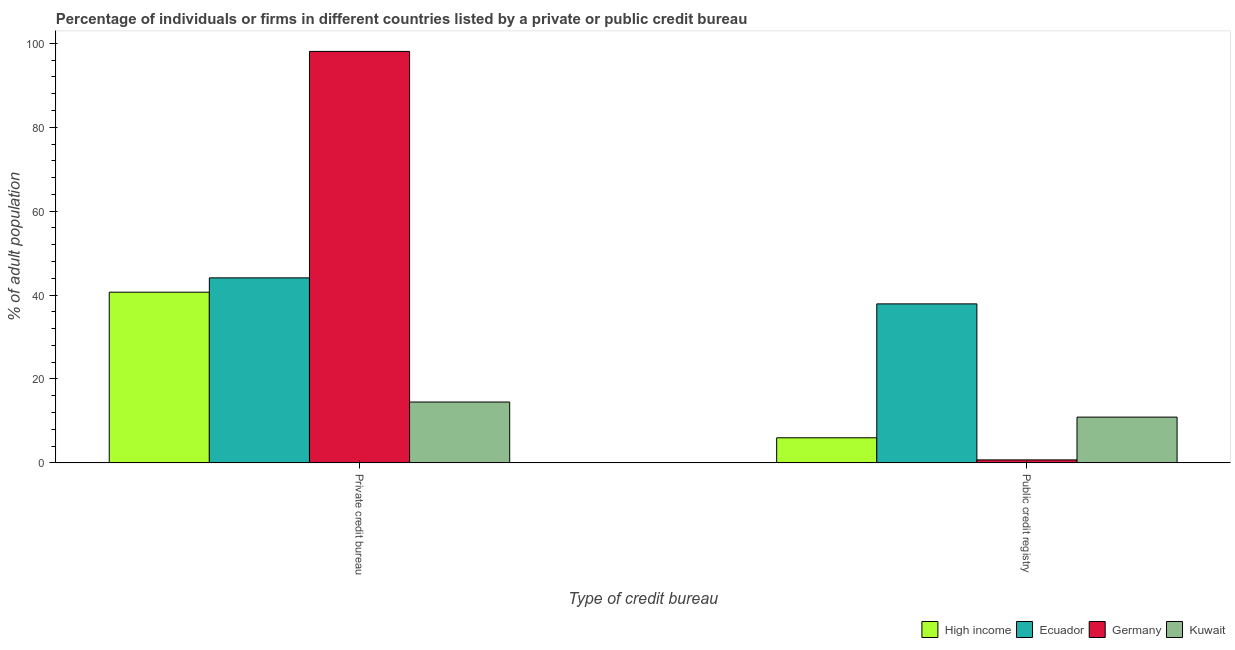How many different coloured bars are there?
Your response must be concise. 4. How many groups of bars are there?
Provide a short and direct response. 2. Are the number of bars per tick equal to the number of legend labels?
Ensure brevity in your answer.  Yes. What is the label of the 1st group of bars from the left?
Offer a very short reply. Private credit bureau. What is the percentage of firms listed by public credit bureau in Germany?
Your answer should be compact. 0.7. Across all countries, what is the maximum percentage of firms listed by public credit bureau?
Your response must be concise. 37.9. Across all countries, what is the minimum percentage of firms listed by public credit bureau?
Provide a succinct answer. 0.7. In which country was the percentage of firms listed by public credit bureau maximum?
Your answer should be compact. Ecuador. What is the total percentage of firms listed by private credit bureau in the graph?
Offer a very short reply. 197.39. What is the difference between the percentage of firms listed by public credit bureau in Kuwait and that in Ecuador?
Offer a terse response. -27. What is the difference between the percentage of firms listed by private credit bureau in Germany and the percentage of firms listed by public credit bureau in High income?
Keep it short and to the point. 92.13. What is the average percentage of firms listed by public credit bureau per country?
Provide a short and direct response. 13.87. What is the difference between the percentage of firms listed by public credit bureau and percentage of firms listed by private credit bureau in High income?
Give a very brief answer. -34.72. In how many countries, is the percentage of firms listed by public credit bureau greater than 36 %?
Give a very brief answer. 1. What is the ratio of the percentage of firms listed by private credit bureau in Ecuador to that in Germany?
Provide a succinct answer. 0.45. In how many countries, is the percentage of firms listed by private credit bureau greater than the average percentage of firms listed by private credit bureau taken over all countries?
Your answer should be very brief. 1. What does the 2nd bar from the left in Public credit registry represents?
Ensure brevity in your answer.  Ecuador. What does the 3rd bar from the right in Private credit bureau represents?
Provide a short and direct response. Ecuador. How many bars are there?
Offer a terse response. 8. How many countries are there in the graph?
Offer a very short reply. 4. Are the values on the major ticks of Y-axis written in scientific E-notation?
Make the answer very short. No. Does the graph contain any zero values?
Give a very brief answer. No. How are the legend labels stacked?
Offer a terse response. Horizontal. What is the title of the graph?
Offer a terse response. Percentage of individuals or firms in different countries listed by a private or public credit bureau. Does "Hungary" appear as one of the legend labels in the graph?
Make the answer very short. No. What is the label or title of the X-axis?
Make the answer very short. Type of credit bureau. What is the label or title of the Y-axis?
Give a very brief answer. % of adult population. What is the % of adult population in High income in Private credit bureau?
Keep it short and to the point. 40.69. What is the % of adult population of Ecuador in Private credit bureau?
Your answer should be very brief. 44.1. What is the % of adult population of Germany in Private credit bureau?
Your response must be concise. 98.1. What is the % of adult population in Kuwait in Private credit bureau?
Your response must be concise. 14.5. What is the % of adult population in High income in Public credit registry?
Make the answer very short. 5.97. What is the % of adult population in Ecuador in Public credit registry?
Your answer should be very brief. 37.9. What is the % of adult population of Kuwait in Public credit registry?
Make the answer very short. 10.9. Across all Type of credit bureau, what is the maximum % of adult population of High income?
Your response must be concise. 40.69. Across all Type of credit bureau, what is the maximum % of adult population in Ecuador?
Provide a short and direct response. 44.1. Across all Type of credit bureau, what is the maximum % of adult population in Germany?
Make the answer very short. 98.1. Across all Type of credit bureau, what is the maximum % of adult population of Kuwait?
Provide a short and direct response. 14.5. Across all Type of credit bureau, what is the minimum % of adult population of High income?
Your answer should be very brief. 5.97. Across all Type of credit bureau, what is the minimum % of adult population in Ecuador?
Your answer should be very brief. 37.9. What is the total % of adult population of High income in the graph?
Provide a succinct answer. 46.66. What is the total % of adult population of Germany in the graph?
Give a very brief answer. 98.8. What is the total % of adult population in Kuwait in the graph?
Your answer should be very brief. 25.4. What is the difference between the % of adult population in High income in Private credit bureau and that in Public credit registry?
Your answer should be very brief. 34.72. What is the difference between the % of adult population of Germany in Private credit bureau and that in Public credit registry?
Offer a very short reply. 97.4. What is the difference between the % of adult population in High income in Private credit bureau and the % of adult population in Ecuador in Public credit registry?
Offer a very short reply. 2.79. What is the difference between the % of adult population of High income in Private credit bureau and the % of adult population of Germany in Public credit registry?
Your response must be concise. 39.99. What is the difference between the % of adult population in High income in Private credit bureau and the % of adult population in Kuwait in Public credit registry?
Offer a very short reply. 29.79. What is the difference between the % of adult population of Ecuador in Private credit bureau and the % of adult population of Germany in Public credit registry?
Offer a terse response. 43.4. What is the difference between the % of adult population of Ecuador in Private credit bureau and the % of adult population of Kuwait in Public credit registry?
Provide a succinct answer. 33.2. What is the difference between the % of adult population of Germany in Private credit bureau and the % of adult population of Kuwait in Public credit registry?
Provide a succinct answer. 87.2. What is the average % of adult population in High income per Type of credit bureau?
Give a very brief answer. 23.33. What is the average % of adult population in Ecuador per Type of credit bureau?
Offer a terse response. 41. What is the average % of adult population of Germany per Type of credit bureau?
Offer a very short reply. 49.4. What is the difference between the % of adult population in High income and % of adult population in Ecuador in Private credit bureau?
Ensure brevity in your answer.  -3.41. What is the difference between the % of adult population of High income and % of adult population of Germany in Private credit bureau?
Your answer should be compact. -57.41. What is the difference between the % of adult population in High income and % of adult population in Kuwait in Private credit bureau?
Provide a short and direct response. 26.19. What is the difference between the % of adult population of Ecuador and % of adult population of Germany in Private credit bureau?
Make the answer very short. -54. What is the difference between the % of adult population of Ecuador and % of adult population of Kuwait in Private credit bureau?
Keep it short and to the point. 29.6. What is the difference between the % of adult population of Germany and % of adult population of Kuwait in Private credit bureau?
Offer a very short reply. 83.6. What is the difference between the % of adult population in High income and % of adult population in Ecuador in Public credit registry?
Provide a short and direct response. -31.93. What is the difference between the % of adult population of High income and % of adult population of Germany in Public credit registry?
Make the answer very short. 5.27. What is the difference between the % of adult population in High income and % of adult population in Kuwait in Public credit registry?
Provide a short and direct response. -4.93. What is the difference between the % of adult population of Ecuador and % of adult population of Germany in Public credit registry?
Give a very brief answer. 37.2. What is the difference between the % of adult population of Ecuador and % of adult population of Kuwait in Public credit registry?
Provide a short and direct response. 27. What is the ratio of the % of adult population in High income in Private credit bureau to that in Public credit registry?
Provide a short and direct response. 6.81. What is the ratio of the % of adult population in Ecuador in Private credit bureau to that in Public credit registry?
Offer a very short reply. 1.16. What is the ratio of the % of adult population in Germany in Private credit bureau to that in Public credit registry?
Make the answer very short. 140.14. What is the ratio of the % of adult population of Kuwait in Private credit bureau to that in Public credit registry?
Ensure brevity in your answer.  1.33. What is the difference between the highest and the second highest % of adult population of High income?
Ensure brevity in your answer.  34.72. What is the difference between the highest and the second highest % of adult population of Ecuador?
Provide a short and direct response. 6.2. What is the difference between the highest and the second highest % of adult population in Germany?
Provide a short and direct response. 97.4. What is the difference between the highest and the second highest % of adult population of Kuwait?
Keep it short and to the point. 3.6. What is the difference between the highest and the lowest % of adult population in High income?
Your response must be concise. 34.72. What is the difference between the highest and the lowest % of adult population of Ecuador?
Offer a very short reply. 6.2. What is the difference between the highest and the lowest % of adult population in Germany?
Your answer should be compact. 97.4. What is the difference between the highest and the lowest % of adult population of Kuwait?
Your answer should be very brief. 3.6. 